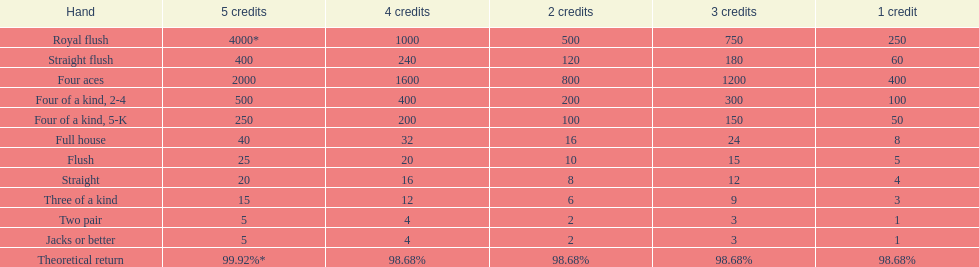For 3 credits, what is the discrepancy in payout between a straight flush and a royal flush? 570. 